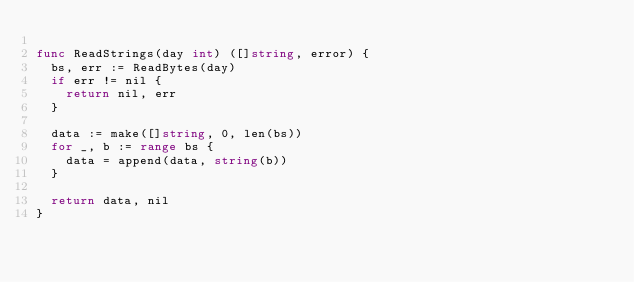Convert code to text. <code><loc_0><loc_0><loc_500><loc_500><_Go_>
func ReadStrings(day int) ([]string, error) {
	bs, err := ReadBytes(day)
	if err != nil {
		return nil, err
	}

	data := make([]string, 0, len(bs))
	for _, b := range bs {
		data = append(data, string(b))
	}

	return data, nil
}
</code> 